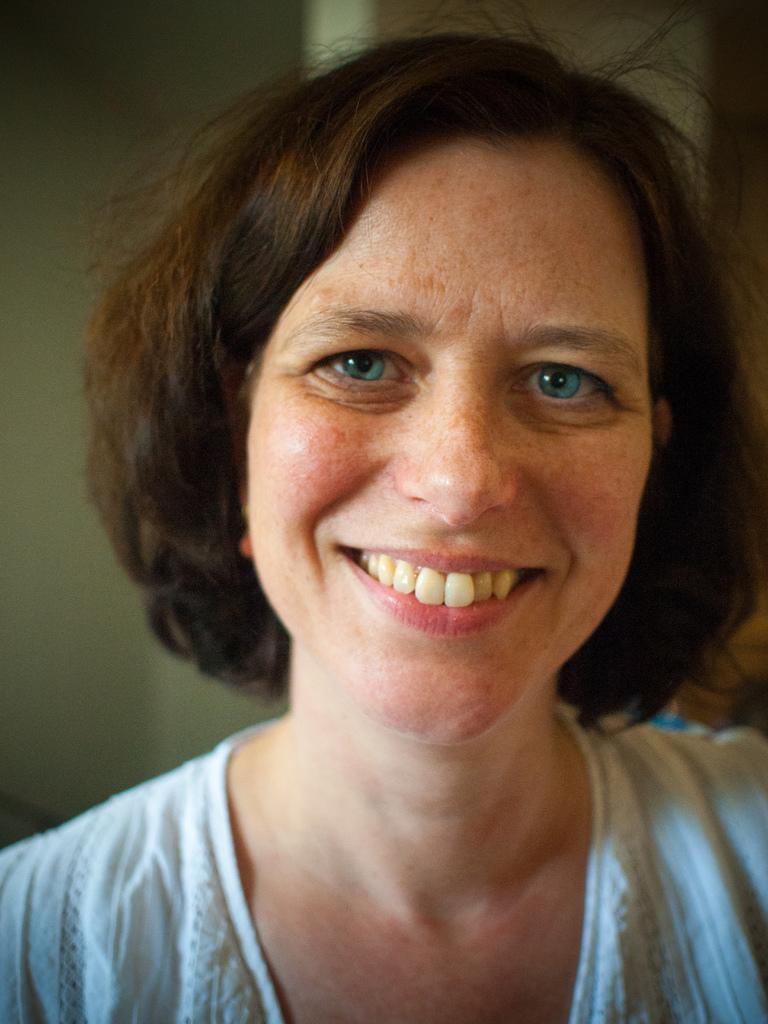Who is the main subject in the image? There is a woman in the image. What is the woman wearing? The woman is wearing a white dress. What is the woman's facial expression in the image? The woman is smiling. Can you describe the background of the image? The background of the image is blurred. What type of credit can be seen in the woman's hand in the image? There is no credit visible in the woman's hand in the image. 